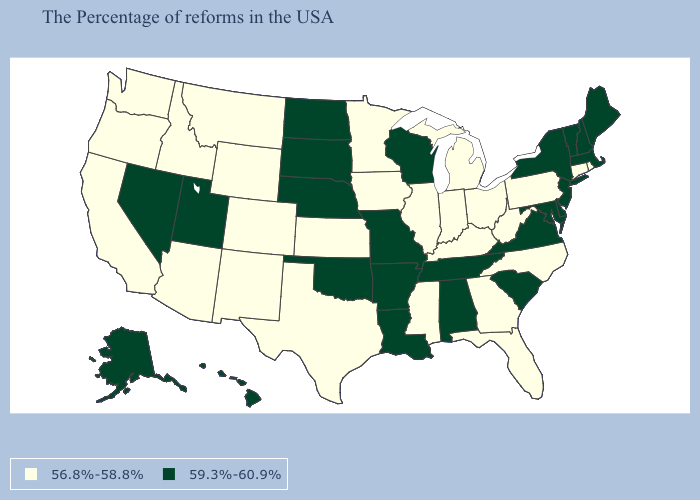What is the lowest value in the USA?
Be succinct. 56.8%-58.8%. Does the first symbol in the legend represent the smallest category?
Short answer required. Yes. Does Arkansas have the same value as West Virginia?
Write a very short answer. No. What is the value of Texas?
Concise answer only. 56.8%-58.8%. Among the states that border Mississippi , which have the lowest value?
Quick response, please. Alabama, Tennessee, Louisiana, Arkansas. What is the value of Alabama?
Quick response, please. 59.3%-60.9%. Does South Carolina have the same value as Arkansas?
Keep it brief. Yes. Among the states that border North Dakota , does South Dakota have the lowest value?
Be succinct. No. Name the states that have a value in the range 56.8%-58.8%?
Concise answer only. Rhode Island, Connecticut, Pennsylvania, North Carolina, West Virginia, Ohio, Florida, Georgia, Michigan, Kentucky, Indiana, Illinois, Mississippi, Minnesota, Iowa, Kansas, Texas, Wyoming, Colorado, New Mexico, Montana, Arizona, Idaho, California, Washington, Oregon. Name the states that have a value in the range 56.8%-58.8%?
Give a very brief answer. Rhode Island, Connecticut, Pennsylvania, North Carolina, West Virginia, Ohio, Florida, Georgia, Michigan, Kentucky, Indiana, Illinois, Mississippi, Minnesota, Iowa, Kansas, Texas, Wyoming, Colorado, New Mexico, Montana, Arizona, Idaho, California, Washington, Oregon. Does New Hampshire have a lower value than Alabama?
Concise answer only. No. Name the states that have a value in the range 56.8%-58.8%?
Keep it brief. Rhode Island, Connecticut, Pennsylvania, North Carolina, West Virginia, Ohio, Florida, Georgia, Michigan, Kentucky, Indiana, Illinois, Mississippi, Minnesota, Iowa, Kansas, Texas, Wyoming, Colorado, New Mexico, Montana, Arizona, Idaho, California, Washington, Oregon. Which states have the highest value in the USA?
Give a very brief answer. Maine, Massachusetts, New Hampshire, Vermont, New York, New Jersey, Delaware, Maryland, Virginia, South Carolina, Alabama, Tennessee, Wisconsin, Louisiana, Missouri, Arkansas, Nebraska, Oklahoma, South Dakota, North Dakota, Utah, Nevada, Alaska, Hawaii. Name the states that have a value in the range 56.8%-58.8%?
Concise answer only. Rhode Island, Connecticut, Pennsylvania, North Carolina, West Virginia, Ohio, Florida, Georgia, Michigan, Kentucky, Indiana, Illinois, Mississippi, Minnesota, Iowa, Kansas, Texas, Wyoming, Colorado, New Mexico, Montana, Arizona, Idaho, California, Washington, Oregon. 